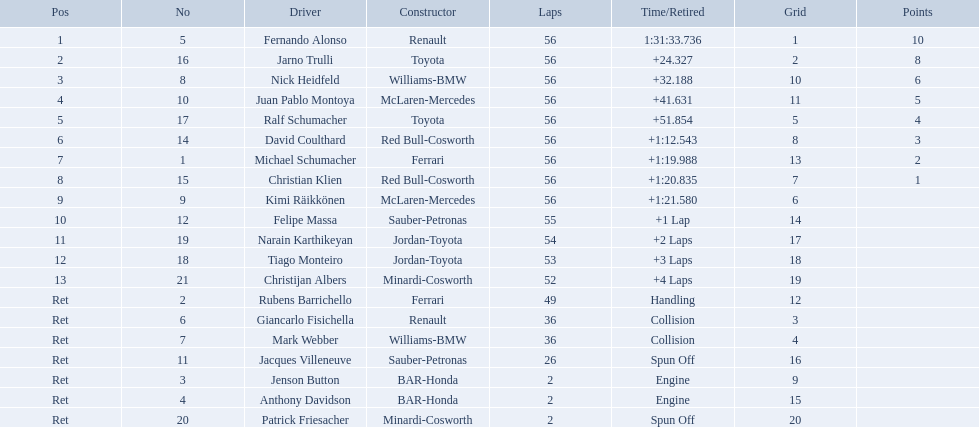Who was fernando alonso's instructor? Renault. How many laps did fernando alonso run? 56. How long did it take alonso to complete the race? 1:31:33.736. Who raced during the 2005 malaysian grand prix? Fernando Alonso, Jarno Trulli, Nick Heidfeld, Juan Pablo Montoya, Ralf Schumacher, David Coulthard, Michael Schumacher, Christian Klien, Kimi Räikkönen, Felipe Massa, Narain Karthikeyan, Tiago Monteiro, Christijan Albers, Rubens Barrichello, Giancarlo Fisichella, Mark Webber, Jacques Villeneuve, Jenson Button, Anthony Davidson, Patrick Friesacher. What were their finishing times? 1:31:33.736, +24.327, +32.188, +41.631, +51.854, +1:12.543, +1:19.988, +1:20.835, +1:21.580, +1 Lap, +2 Laps, +3 Laps, +4 Laps, Handling, Collision, Collision, Spun Off, Engine, Engine, Spun Off. What was fernando alonso's finishing time? 1:31:33.736. What rank did fernando alonso achieve? 1. How long did it take alonso to finish the competition? 1:31:33.736. Who was fernando alonso's coach? Renault. How many loops did fernando alonso go through? 56. How much duration did it take alonso to accomplish the race? 1:31:33.736. What position did fernando alonso end up in? 1. How much time did it take alonso to complete the race? 1:31:33.736. Who was fernando alonso's mentor? Renault. How many rounds did fernando alonso perform? 56. How long did it take alonso to conclude the race? 1:31:33.736. Who guided fernando alonso as his teacher? Renault. How many laps did alonso complete? 56. What was the time taken by alonso to finish the race? 1:31:33.736. At which position did fernando alonso end up? 1. What was the duration of alonso's race completion? 1:31:33.736. In which rank did fernando alonso conclude the race? 1. How much time did alonso require to finish the race? 1:31:33.736. What was fernando alonso's finishing position? 1. What was the time taken by alonso to complete the race? 1:31:33.736. 